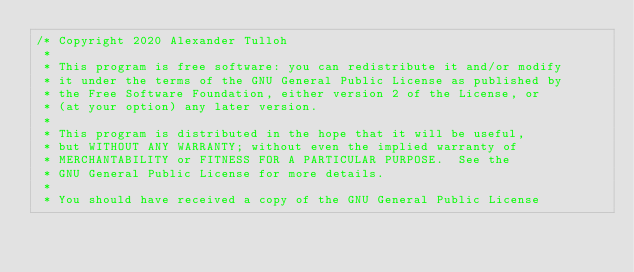<code> <loc_0><loc_0><loc_500><loc_500><_C_>/* Copyright 2020 Alexander Tulloh
 *
 * This program is free software: you can redistribute it and/or modify
 * it under the terms of the GNU General Public License as published by
 * the Free Software Foundation, either version 2 of the License, or
 * (at your option) any later version.
 *
 * This program is distributed in the hope that it will be useful,
 * but WITHOUT ANY WARRANTY; without even the implied warranty of
 * MERCHANTABILITY or FITNESS FOR A PARTICULAR PURPOSE.  See the
 * GNU General Public License for more details.
 *
 * You should have received a copy of the GNU General Public License</code> 